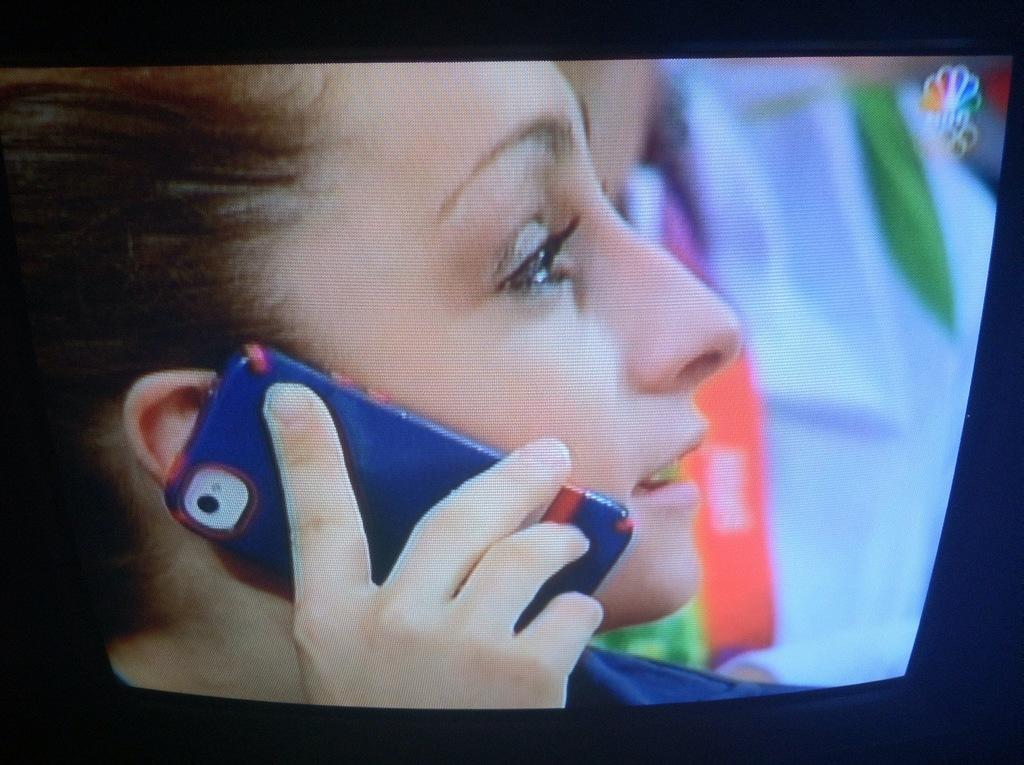What is the main subject in the center of the image? There is a screen in the center of the image. What can be seen on the screen? A person is visible on the screen. What is the person holding on the screen? The person is holding a mobile on the screen. What type of toys can be seen on the road in the image? There is no road or toys present in the image; it only features a screen with a person holding a mobile. 